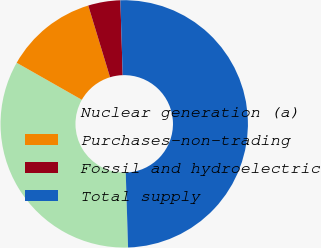<chart> <loc_0><loc_0><loc_500><loc_500><pie_chart><fcel>Nuclear generation (a)<fcel>Purchases-non-trading<fcel>Fossil and hydroelectric<fcel>Total supply<nl><fcel>33.72%<fcel>12.08%<fcel>4.2%<fcel>50.0%<nl></chart> 